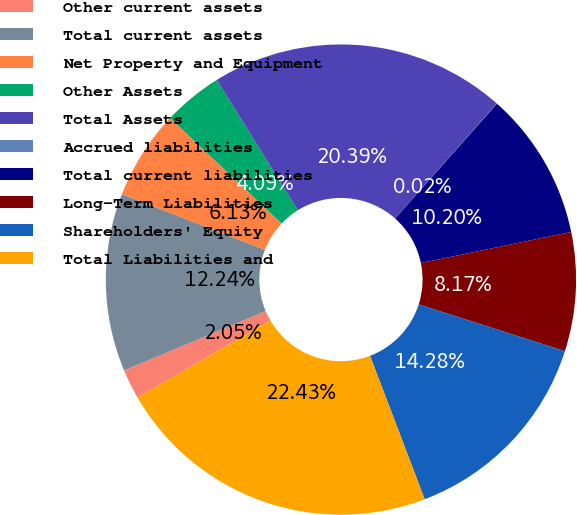<chart> <loc_0><loc_0><loc_500><loc_500><pie_chart><fcel>Other current assets<fcel>Total current assets<fcel>Net Property and Equipment<fcel>Other Assets<fcel>Total Assets<fcel>Accrued liabilities<fcel>Total current liabilities<fcel>Long-Term Liabilities<fcel>Shareholders' Equity<fcel>Total Liabilities and<nl><fcel>2.05%<fcel>12.24%<fcel>6.13%<fcel>4.09%<fcel>20.39%<fcel>0.02%<fcel>10.2%<fcel>8.17%<fcel>14.28%<fcel>22.43%<nl></chart> 